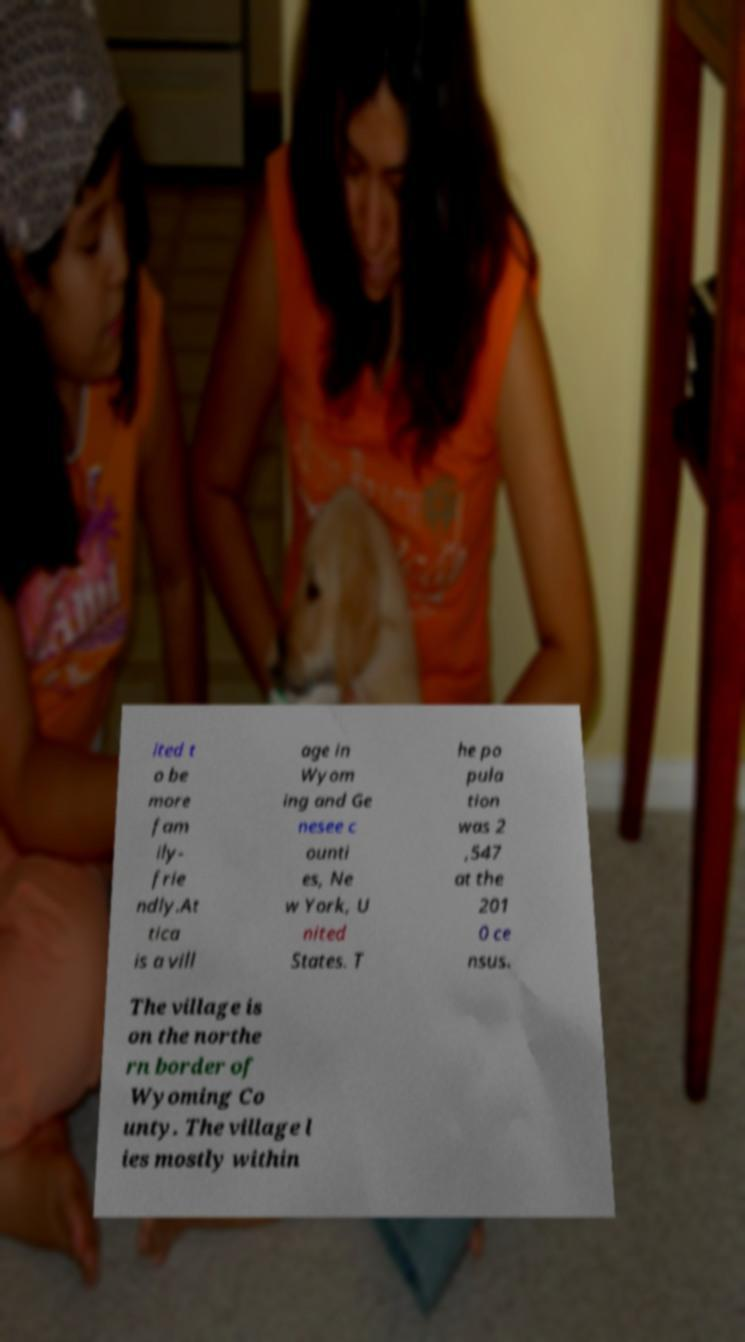For documentation purposes, I need the text within this image transcribed. Could you provide that? ited t o be more fam ily- frie ndly.At tica is a vill age in Wyom ing and Ge nesee c ounti es, Ne w York, U nited States. T he po pula tion was 2 ,547 at the 201 0 ce nsus. The village is on the northe rn border of Wyoming Co unty. The village l ies mostly within 